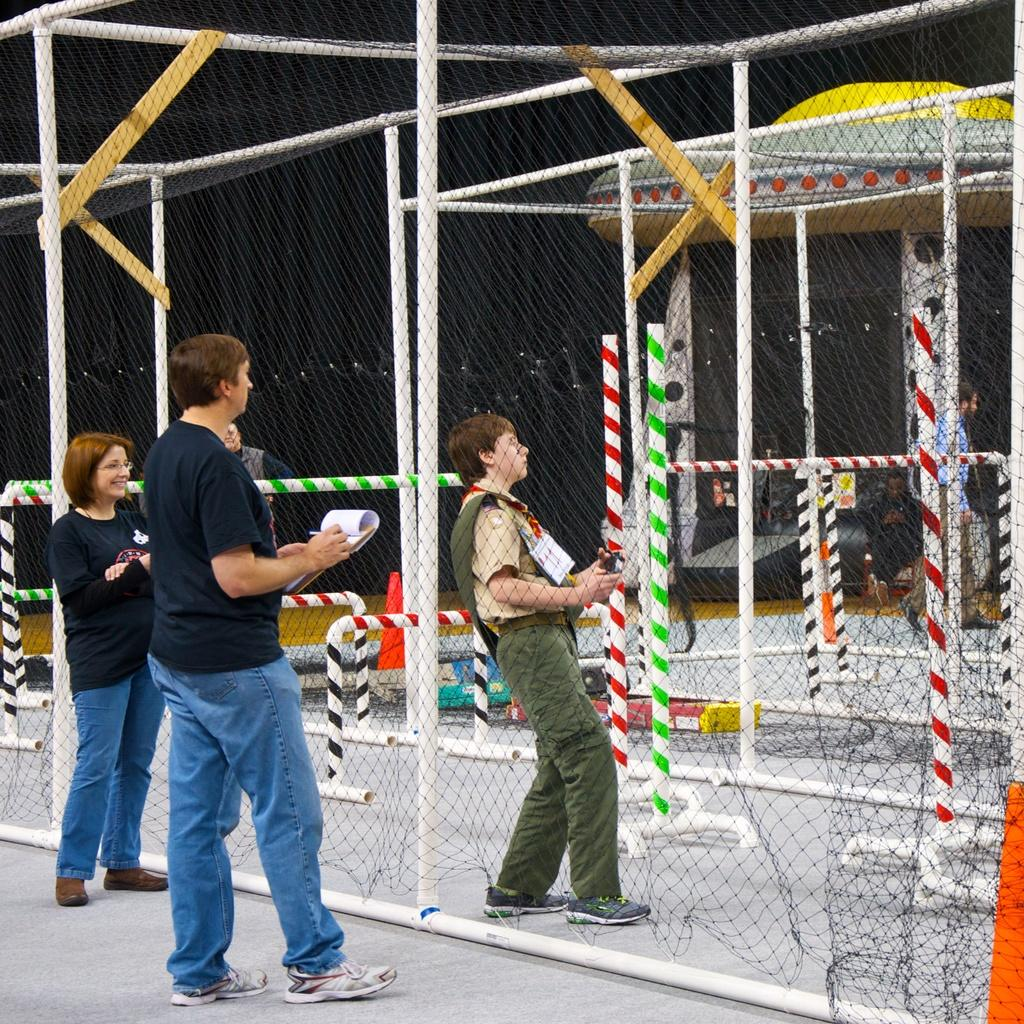How many people are in the image? There are people in the image, but the exact number is not specified. What is the man in the center of the image doing? The man in the center of the image is standing and holding a book. What can be seen in the background of the image? In the background of the image, there are poles, a net, and cones. What type of crack is visible on the man's throat in the image? There is no crack visible on the man's throat in the image. What is the end result of the activity depicted in the image? The facts provided do not give enough information to determine the end result of the activity depicted in the image. 